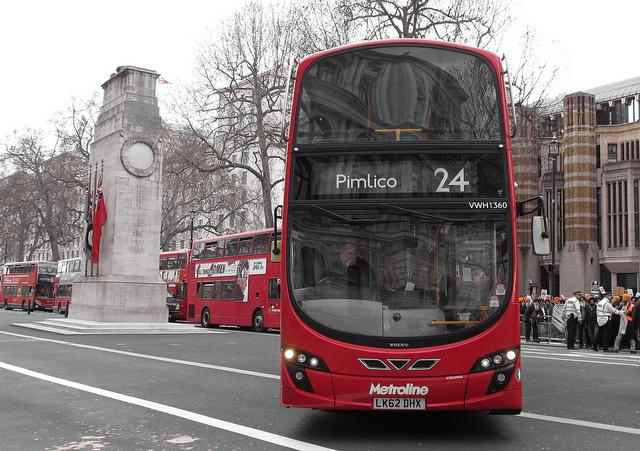What number bus is this?
Quick response, please. 24. Are there passengers in the bus?
Keep it brief. Yes. What color is the bus?
Keep it brief. Red. 